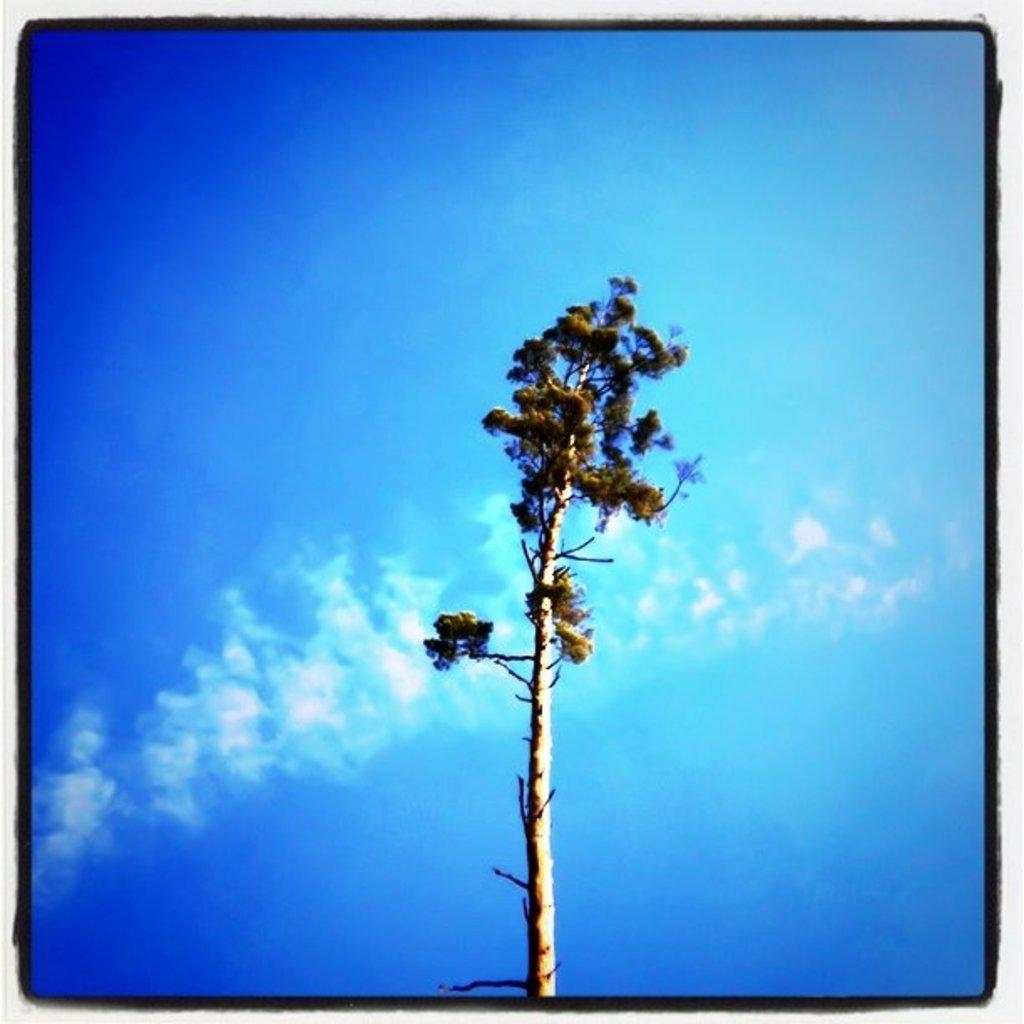What is the main subject in the center of the image? There is a tree in the center of the image. What can be seen in the background of the image? There is sky visible in the background of the image. What type of disgust can be seen on the tree's face in the image? There is no face or expression of disgust on the tree in the image, as trees are inanimate objects and do not have facial expressions. 